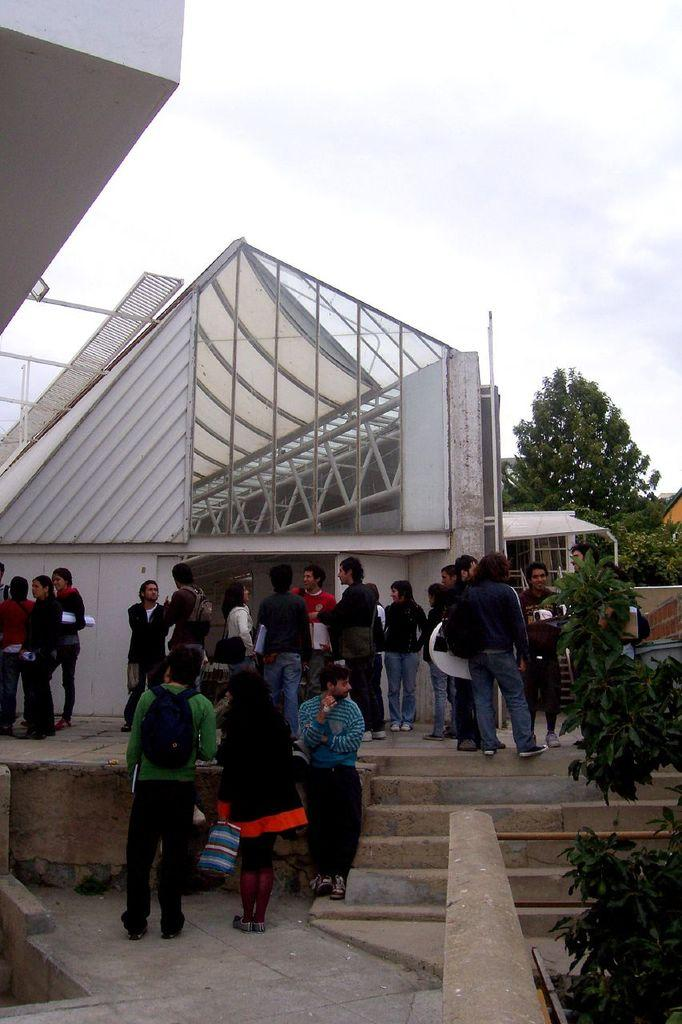How many people are in the image? There are many people in the image. What can be seen behind the people in the image? The people are standing in front of some architecture. What is present on the right side of the image? There are trees and plants on the right side of the image. What type of thread is being used by the people in the image? There is no thread present in the image; the people are simply standing in front of some architecture. What kind of hat is being worn by the plants in the image? There are no hats present in the image, as the plants are not wearing any. 